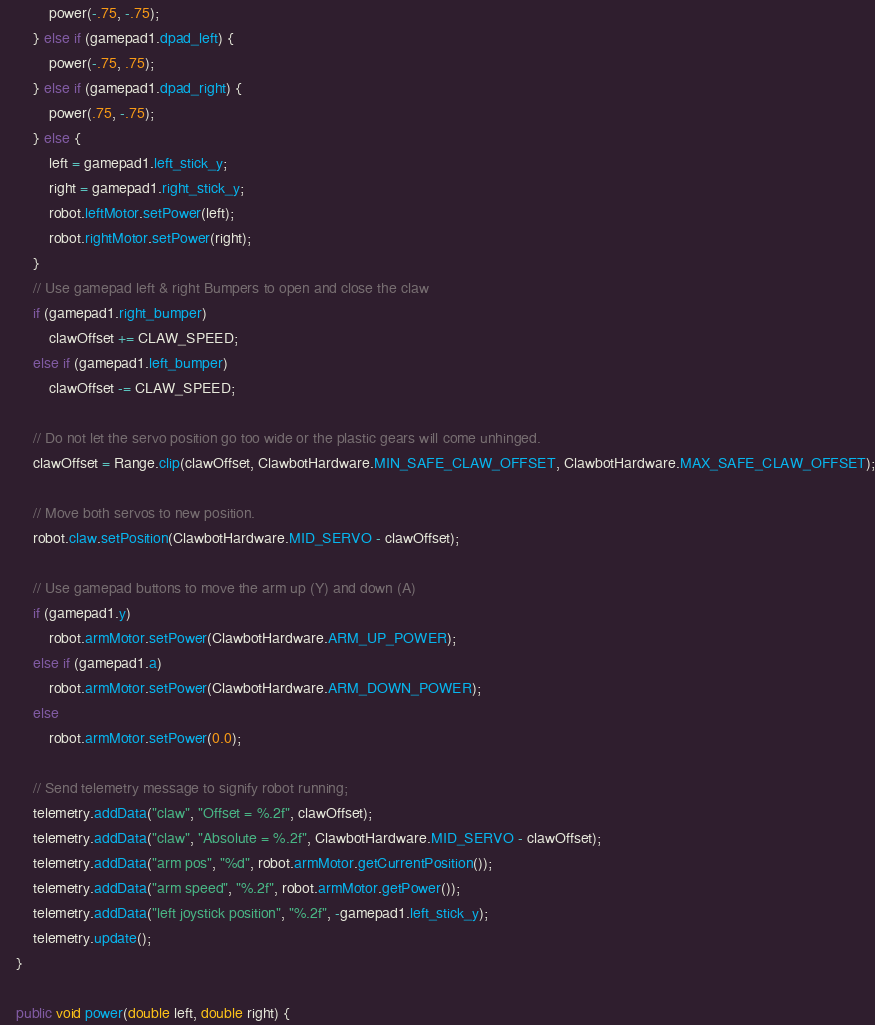Convert code to text. <code><loc_0><loc_0><loc_500><loc_500><_Java_>            power(-.75, -.75);
        } else if (gamepad1.dpad_left) {
            power(-.75, .75);
        } else if (gamepad1.dpad_right) {
            power(.75, -.75);
        } else {
            left = gamepad1.left_stick_y;
            right = gamepad1.right_stick_y;
            robot.leftMotor.setPower(left);
            robot.rightMotor.setPower(right);
        }
        // Use gamepad left & right Bumpers to open and close the claw
        if (gamepad1.right_bumper)
            clawOffset += CLAW_SPEED;
        else if (gamepad1.left_bumper)
            clawOffset -= CLAW_SPEED;

        // Do not let the servo position go too wide or the plastic gears will come unhinged.
        clawOffset = Range.clip(clawOffset, ClawbotHardware.MIN_SAFE_CLAW_OFFSET, ClawbotHardware.MAX_SAFE_CLAW_OFFSET);

        // Move both servos to new position.
        robot.claw.setPosition(ClawbotHardware.MID_SERVO - clawOffset);

        // Use gamepad buttons to move the arm up (Y) and down (A)
        if (gamepad1.y)
            robot.armMotor.setPower(ClawbotHardware.ARM_UP_POWER);
        else if (gamepad1.a)
            robot.armMotor.setPower(ClawbotHardware.ARM_DOWN_POWER);
        else
            robot.armMotor.setPower(0.0);

        // Send telemetry message to signify robot running;
        telemetry.addData("claw", "Offset = %.2f", clawOffset);
        telemetry.addData("claw", "Absolute = %.2f", ClawbotHardware.MID_SERVO - clawOffset);
        telemetry.addData("arm pos", "%d", robot.armMotor.getCurrentPosition());
        telemetry.addData("arm speed", "%.2f", robot.armMotor.getPower());
        telemetry.addData("left joystick position", "%.2f", -gamepad1.left_stick_y);
        telemetry.update();
    }

    public void power(double left, double right) {</code> 